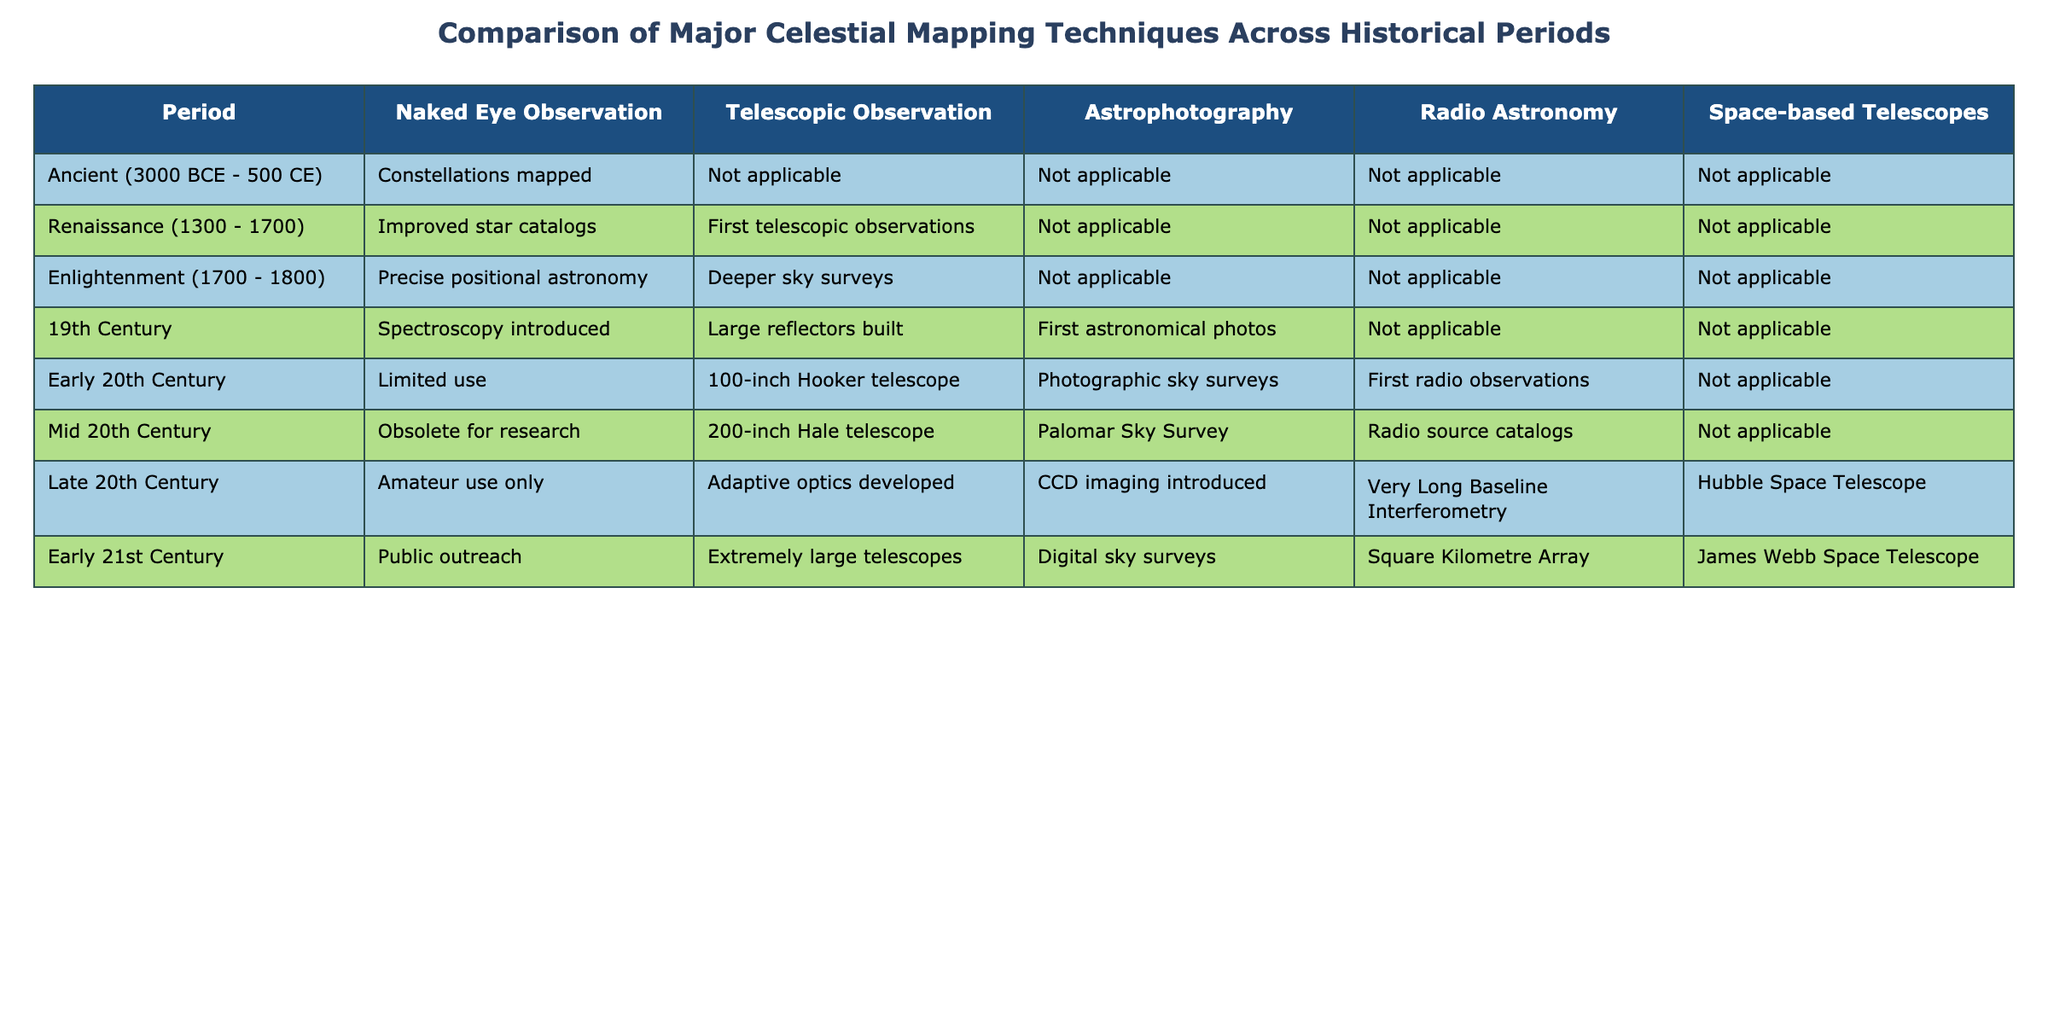What celestial mapping technique was prominent during the Late 20th Century? The table indicates that during the Late 20th Century, the techniques included amateur use of naked eye observation, adaptive optics for telescopic observation, CCD imaging, Very Long Baseline Interferometry for radio astronomy, and the Hubble Space Telescope for space-based observation.
Answer: Multiple techniques Which period introduced the first astronomical photographs? According to the table, the 19th Century marks the introduction of the first astronomical photographs under the technique of astrophotography.
Answer: 19th Century Did any techniques become obsolete during the Mid 20th Century? The table shows that naked eye observation became obsolete for research during the Mid 20th Century, as reflected in the corresponding column.
Answer: Yes Compare the usage of telescopic observation in the Early 21st Century to the Ancient period. The table illustrates that in the Early 21st Century, telescopic observation featured extremely large telescopes, whereas in the Ancient period, telescopic observation was noted as not applicable. Hence, the usage increased significantly over time.
Answer: Increased significantly What was the primary observation method in the Renaissance period? The table identifies that improved star catalogs represent the primary observation method during the Renaissance period, indicating a step forward in celestial mapping techniques.
Answer: Improved star catalogs How many celestial mapping techniques were in use during the Early 20th Century? Reviewing the table for the Early 20th Century, there are four techniques listed: limited use for naked eye observation, the 100-inch Hooker telescope for telescopic observation, photographic sky surveys for astrophotography, and first radio observations for radio astronomy. Therefore, the count is four.
Answer: Four Did any celestial mapping technique emerge in the 19th Century that was not present in the Enlightenment period? The table indicates that spectroscopy and large reflectors emerged in the 19th Century specifically under telescopic observation, while the Enlightenment period lacks such mention, confirming the emergence of these techniques.
Answer: Yes What is the relationship between radio astronomy techniques and space-based telescopes in the Late 20th Century? The table distinguishes that in the Late 20th Century, radio astronomy involved Very Long Baseline Interferometry while space-based telescopes introduced the Hubble Space Telescope. This indicates that both fields developed their techniques independently but concurrently during that time.
Answer: Concurrent development How many periods featured the use of radio astronomy techniques? Upon examining the table, radio astronomy techniques were employed during the Early 20th Century, Mid 20th Century, Late 20th Century, and Early 21st Century, totaling four periods.
Answer: Four periods What was the first period to exhibit significant advancements in celestial cartography using telescopic observation? The table indicates that the Renaissance period marks the first significant telescopic observations, signaling advancements beyond naked eye observations.
Answer: Renaissance 